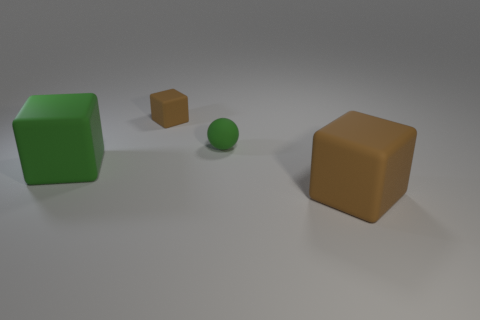Are there an equal number of things behind the small green matte thing and tiny matte blocks?
Provide a succinct answer. Yes. How many tiny brown cubes have the same material as the ball?
Your answer should be very brief. 1. Is the number of big green shiny cubes less than the number of blocks?
Offer a very short reply. Yes. There is a big object that is to the right of the green block; does it have the same color as the small cube?
Offer a terse response. Yes. What number of rubber blocks are behind the large rubber object on the left side of the brown rubber thing in front of the tiny brown matte block?
Give a very brief answer. 1. There is a green cube; how many cubes are right of it?
Your answer should be very brief. 2. The other large matte thing that is the same shape as the large brown thing is what color?
Offer a very short reply. Green. There is a thing that is both on the left side of the green matte ball and behind the green matte cube; what material is it?
Ensure brevity in your answer.  Rubber. There is a brown rubber object that is behind the matte sphere; does it have the same size as the sphere?
Your answer should be very brief. Yes. What is the material of the small green object?
Your answer should be compact. Rubber. 